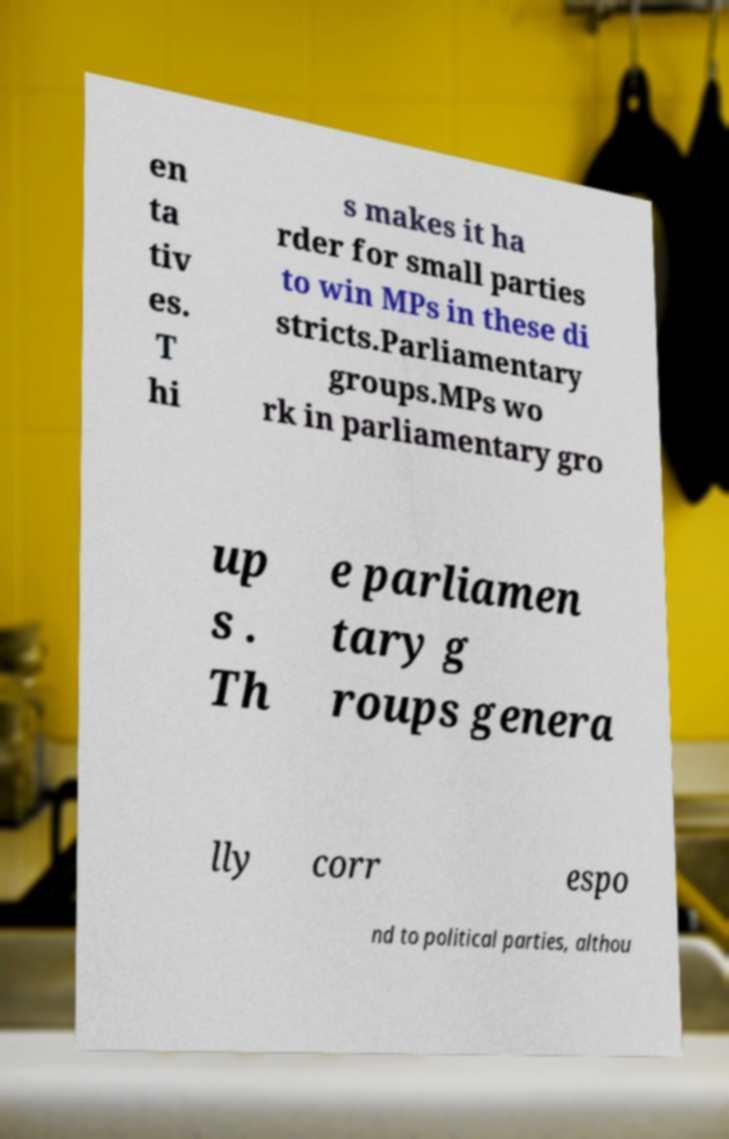For documentation purposes, I need the text within this image transcribed. Could you provide that? en ta tiv es. T hi s makes it ha rder for small parties to win MPs in these di stricts.Parliamentary groups.MPs wo rk in parliamentary gro up s . Th e parliamen tary g roups genera lly corr espo nd to political parties, althou 